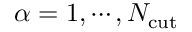Convert formula to latex. <formula><loc_0><loc_0><loc_500><loc_500>\alpha = 1 , \cdots , N _ { c u t }</formula> 